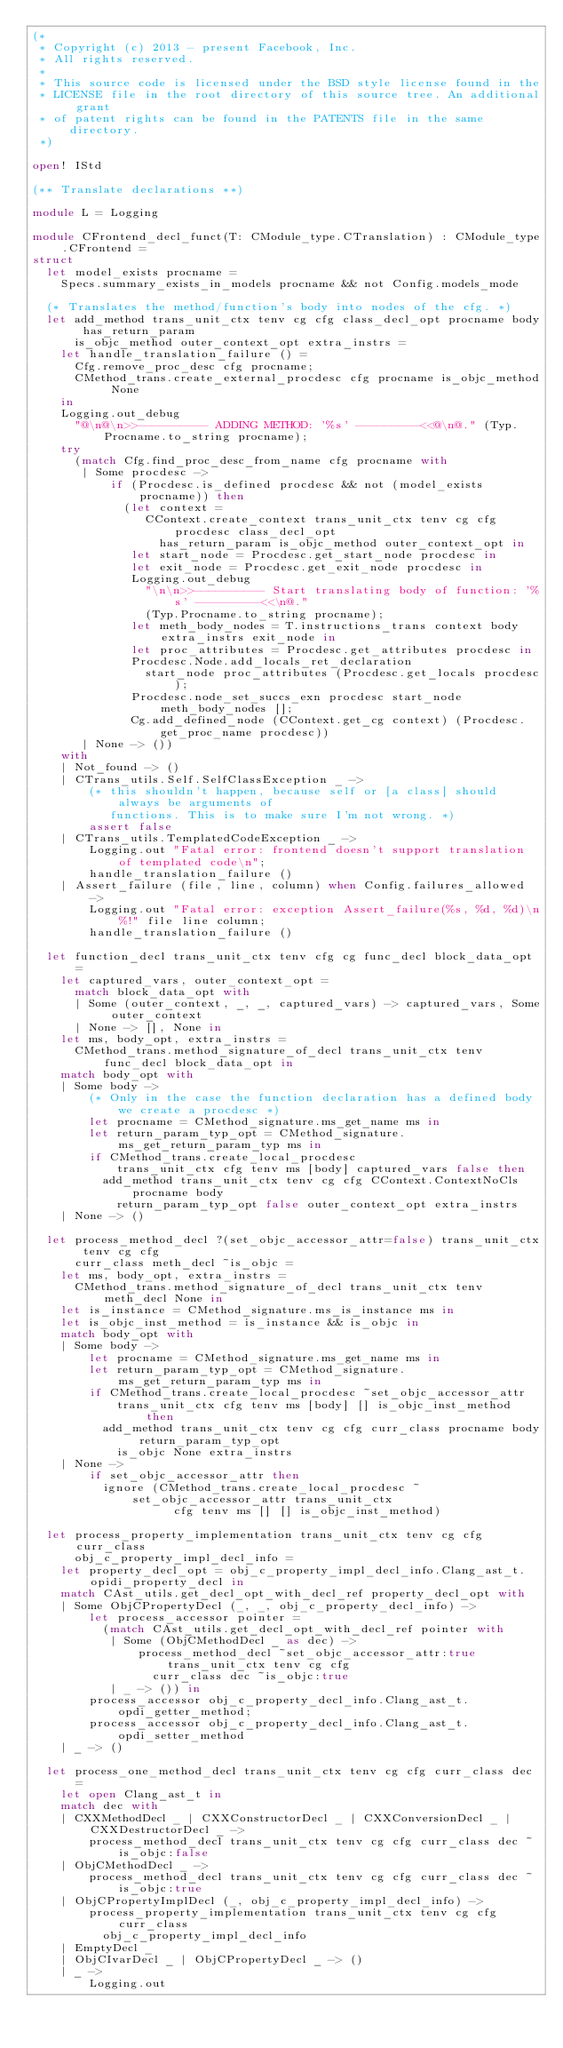<code> <loc_0><loc_0><loc_500><loc_500><_OCaml_>(*
 * Copyright (c) 2013 - present Facebook, Inc.
 * All rights reserved.
 *
 * This source code is licensed under the BSD style license found in the
 * LICENSE file in the root directory of this source tree. An additional grant
 * of patent rights can be found in the PATENTS file in the same directory.
 *)

open! IStd

(** Translate declarations **)

module L = Logging

module CFrontend_decl_funct(T: CModule_type.CTranslation) : CModule_type.CFrontend =
struct
  let model_exists procname =
    Specs.summary_exists_in_models procname && not Config.models_mode

  (* Translates the method/function's body into nodes of the cfg. *)
  let add_method trans_unit_ctx tenv cg cfg class_decl_opt procname body has_return_param
      is_objc_method outer_context_opt extra_instrs =
    let handle_translation_failure () =
      Cfg.remove_proc_desc cfg procname;
      CMethod_trans.create_external_procdesc cfg procname is_objc_method None
    in
    Logging.out_debug
      "@\n@\n>>---------- ADDING METHOD: '%s' ---------<<@\n@." (Typ.Procname.to_string procname);
    try
      (match Cfg.find_proc_desc_from_name cfg procname with
       | Some procdesc ->
           if (Procdesc.is_defined procdesc && not (model_exists procname)) then
             (let context =
                CContext.create_context trans_unit_ctx tenv cg cfg procdesc class_decl_opt
                  has_return_param is_objc_method outer_context_opt in
              let start_node = Procdesc.get_start_node procdesc in
              let exit_node = Procdesc.get_exit_node procdesc in
              Logging.out_debug
                "\n\n>>---------- Start translating body of function: '%s' ---------<<\n@."
                (Typ.Procname.to_string procname);
              let meth_body_nodes = T.instructions_trans context body extra_instrs exit_node in
              let proc_attributes = Procdesc.get_attributes procdesc in
              Procdesc.Node.add_locals_ret_declaration
                start_node proc_attributes (Procdesc.get_locals procdesc);
              Procdesc.node_set_succs_exn procdesc start_node meth_body_nodes [];
              Cg.add_defined_node (CContext.get_cg context) (Procdesc.get_proc_name procdesc))
       | None -> ())
    with
    | Not_found -> ()
    | CTrans_utils.Self.SelfClassException _ ->
        (* this shouldn't happen, because self or [a class] should always be arguments of
           functions. This is to make sure I'm not wrong. *)
        assert false
    | CTrans_utils.TemplatedCodeException _ ->
        Logging.out "Fatal error: frontend doesn't support translation of templated code\n";
        handle_translation_failure ()
    | Assert_failure (file, line, column) when Config.failures_allowed ->
        Logging.out "Fatal error: exception Assert_failure(%s, %d, %d)\n%!" file line column;
        handle_translation_failure ()

  let function_decl trans_unit_ctx tenv cfg cg func_decl block_data_opt =
    let captured_vars, outer_context_opt =
      match block_data_opt with
      | Some (outer_context, _, _, captured_vars) -> captured_vars, Some outer_context
      | None -> [], None in
    let ms, body_opt, extra_instrs =
      CMethod_trans.method_signature_of_decl trans_unit_ctx tenv func_decl block_data_opt in
    match body_opt with
    | Some body ->
        (* Only in the case the function declaration has a defined body we create a procdesc *)
        let procname = CMethod_signature.ms_get_name ms in
        let return_param_typ_opt = CMethod_signature.ms_get_return_param_typ ms in
        if CMethod_trans.create_local_procdesc
            trans_unit_ctx cfg tenv ms [body] captured_vars false then
          add_method trans_unit_ctx tenv cg cfg CContext.ContextNoCls procname body
            return_param_typ_opt false outer_context_opt extra_instrs
    | None -> ()

  let process_method_decl ?(set_objc_accessor_attr=false) trans_unit_ctx tenv cg cfg
      curr_class meth_decl ~is_objc =
    let ms, body_opt, extra_instrs =
      CMethod_trans.method_signature_of_decl trans_unit_ctx tenv meth_decl None in
    let is_instance = CMethod_signature.ms_is_instance ms in
    let is_objc_inst_method = is_instance && is_objc in
    match body_opt with
    | Some body ->
        let procname = CMethod_signature.ms_get_name ms in
        let return_param_typ_opt = CMethod_signature.ms_get_return_param_typ ms in
        if CMethod_trans.create_local_procdesc ~set_objc_accessor_attr
            trans_unit_ctx cfg tenv ms [body] [] is_objc_inst_method then
          add_method trans_unit_ctx tenv cg cfg curr_class procname body return_param_typ_opt
            is_objc None extra_instrs
    | None ->
        if set_objc_accessor_attr then
          ignore (CMethod_trans.create_local_procdesc ~set_objc_accessor_attr trans_unit_ctx
                    cfg tenv ms [] [] is_objc_inst_method)

  let process_property_implementation trans_unit_ctx tenv cg cfg curr_class
      obj_c_property_impl_decl_info =
    let property_decl_opt = obj_c_property_impl_decl_info.Clang_ast_t.opidi_property_decl in
    match CAst_utils.get_decl_opt_with_decl_ref property_decl_opt with
    | Some ObjCPropertyDecl (_, _, obj_c_property_decl_info) ->
        let process_accessor pointer =
          (match CAst_utils.get_decl_opt_with_decl_ref pointer with
           | Some (ObjCMethodDecl _ as dec) ->
               process_method_decl ~set_objc_accessor_attr:true trans_unit_ctx tenv cg cfg
                 curr_class dec ~is_objc:true
           | _ -> ()) in
        process_accessor obj_c_property_decl_info.Clang_ast_t.opdi_getter_method;
        process_accessor obj_c_property_decl_info.Clang_ast_t.opdi_setter_method
    | _ -> ()

  let process_one_method_decl trans_unit_ctx tenv cg cfg curr_class dec =
    let open Clang_ast_t in
    match dec with
    | CXXMethodDecl _ | CXXConstructorDecl _ | CXXConversionDecl _ | CXXDestructorDecl _ ->
        process_method_decl trans_unit_ctx tenv cg cfg curr_class dec ~is_objc:false
    | ObjCMethodDecl _ ->
        process_method_decl trans_unit_ctx tenv cg cfg curr_class dec ~is_objc:true
    | ObjCPropertyImplDecl (_, obj_c_property_impl_decl_info) ->
        process_property_implementation trans_unit_ctx tenv cg cfg curr_class
          obj_c_property_impl_decl_info
    | EmptyDecl _
    | ObjCIvarDecl _ | ObjCPropertyDecl _ -> ()
    | _ ->
        Logging.out</code> 